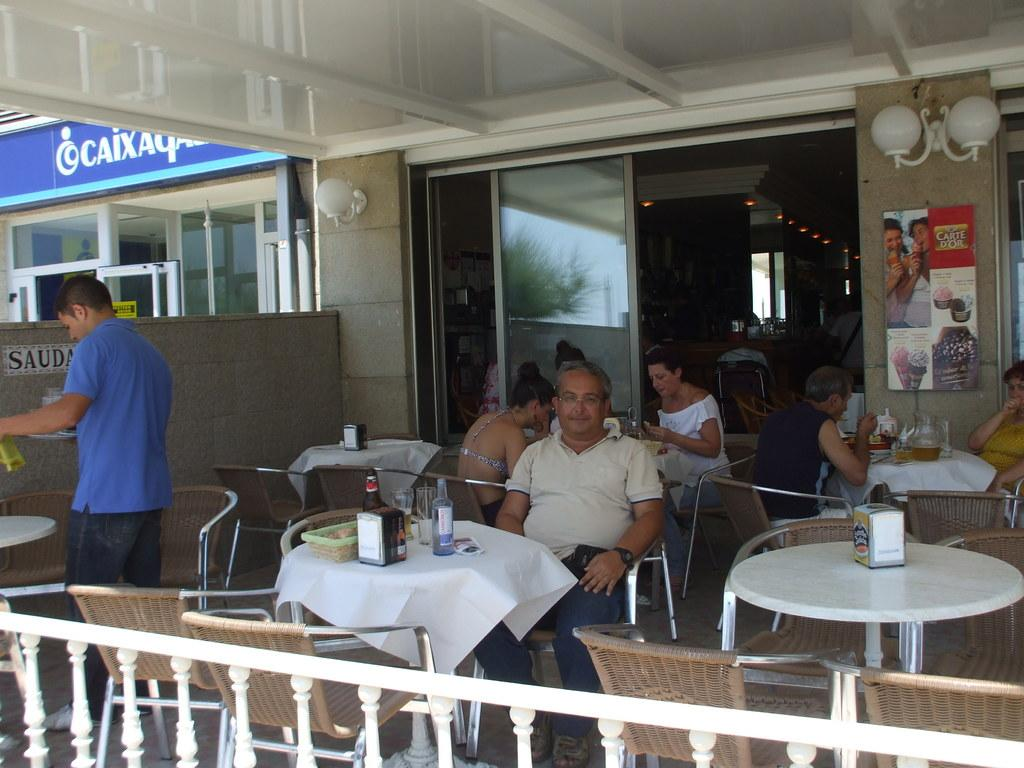Who is present in the image? There are people in the image. What are the people doing in the image? The people are sitting on chairs and having drinks. What type of pail can be seen being used for rubbing in the image? There is no pail present in the image, nor is anyone rubbing anything. 